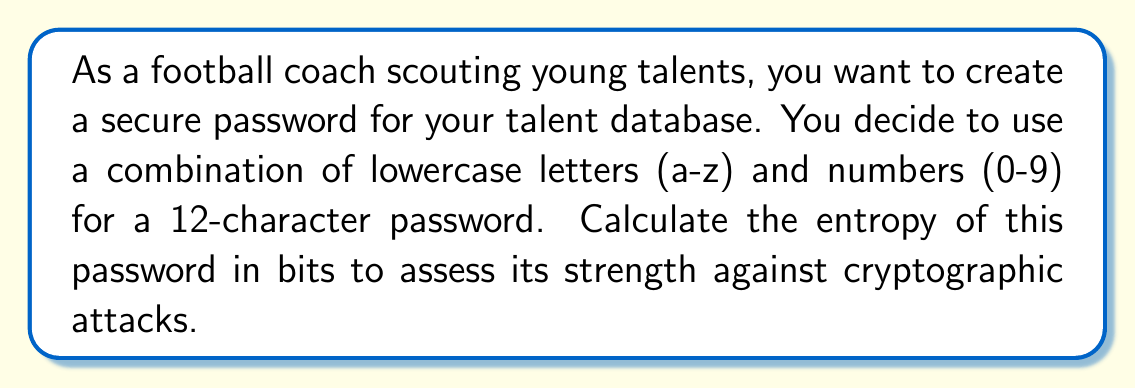Provide a solution to this math problem. To calculate the entropy of a password, we use the formula:

$$ E = L \log_2(R) $$

Where:
$E$ = Entropy in bits
$L$ = Length of the password
$R$ = Range of possible characters

Step 1: Determine the length of the password (L)
$L = 12$ characters

Step 2: Calculate the range of possible characters (R)
Lowercase letters: 26
Numbers: 10
Total: $R = 26 + 10 = 36$ possible characters

Step 3: Apply the entropy formula
$$ E = 12 \log_2(36) $$

Step 4: Calculate $\log_2(36)$
$$ \log_2(36) \approx 5.17 $$

Step 5: Multiply by the password length
$$ E = 12 \times 5.17 \approx 62.04 \text{ bits} $$

Therefore, the entropy of the password is approximately 62.04 bits.
Answer: 62.04 bits 